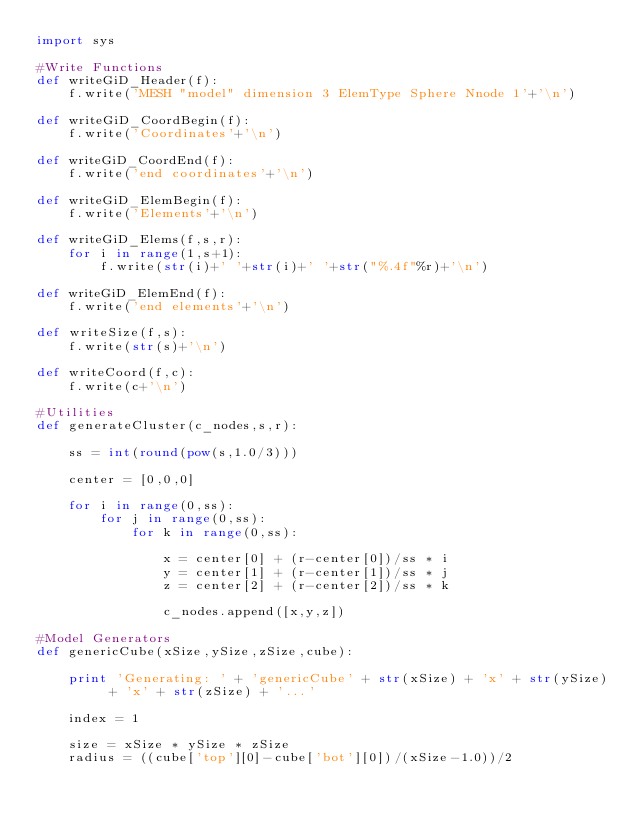<code> <loc_0><loc_0><loc_500><loc_500><_Python_>import sys

#Write Functions
def writeGiD_Header(f):
    f.write('MESH "model" dimension 3 ElemType Sphere Nnode 1'+'\n')
  
def writeGiD_CoordBegin(f):
    f.write('Coordinates'+'\n')
  
def writeGiD_CoordEnd(f):
    f.write('end coordinates'+'\n')
  
def writeGiD_ElemBegin(f):
    f.write('Elements'+'\n')

def writeGiD_Elems(f,s,r): 
    for i in range(1,s+1):
        f.write(str(i)+' '+str(i)+' '+str("%.4f"%r)+'\n')
  
def writeGiD_ElemEnd(f):
    f.write('end elements'+'\n')
  
def writeSize(f,s):
    f.write(str(s)+'\n')
  
def writeCoord(f,c):
    f.write(c+'\n')
    
#Utilities
def generateCluster(c_nodes,s,r):
  
    ss = int(round(pow(s,1.0/3)))
    
    center = [0,0,0]
    
    for i in range(0,ss):
        for j in range(0,ss):
            for k in range(0,ss):
              
                x = center[0] + (r-center[0])/ss * i
                y = center[1] + (r-center[1])/ss * j
                z = center[2] + (r-center[2])/ss * k
              
                c_nodes.append([x,y,z])

#Model Generators
def genericCube(xSize,ySize,zSize,cube):
  
    print 'Generating: ' + 'genericCube' + str(xSize) + 'x' + str(ySize) + 'x' + str(zSize) + '...'
    
    index = 1
    
    size = xSize * ySize * zSize
    radius = ((cube['top'][0]-cube['bot'][0])/(xSize-1.0))/2
    </code> 